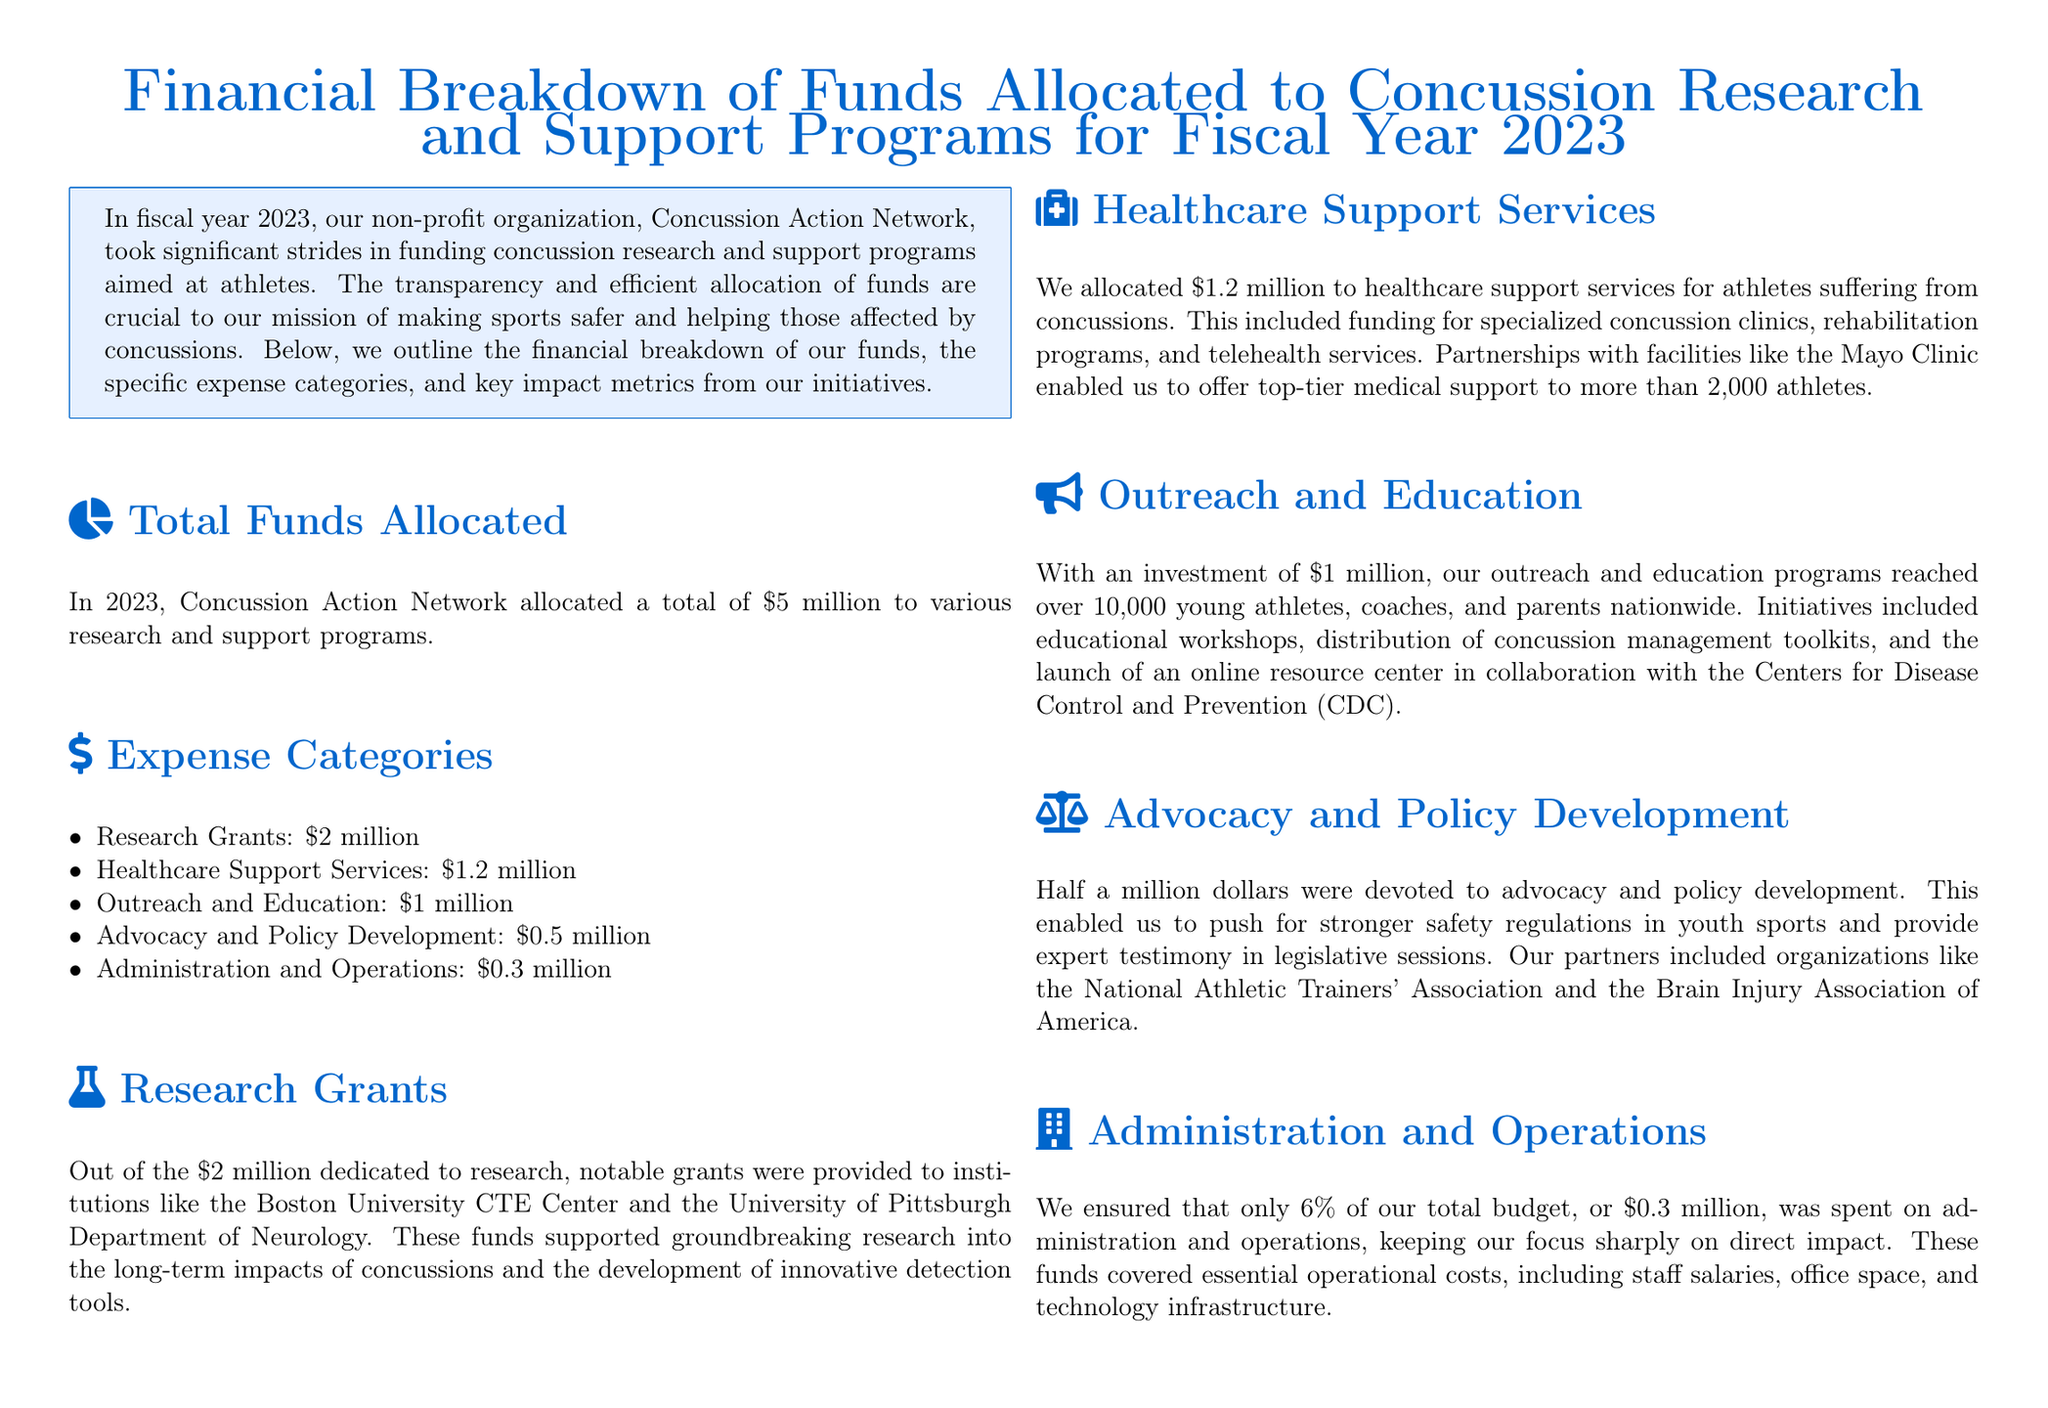What is the total funds allocated? The total funds allocated is stated at the beginning of the document, amounting to $5 million.
Answer: $5 million How much was allocated to research grants? The document specifies that $2 million was allocated to research grants.
Answer: $2 million Which organization received research grants? The document mentions that significant grants were given to institutions, specifically the Boston University CTE Center and the University of Pittsburgh Department of Neurology.
Answer: Boston University CTE Center and the University of Pittsburgh How many athletes received healthcare support services? The document states that more than 2,000 athletes received direct healthcare services through the allocated funding.
Answer: Over 2,000 athletes What percentage of the budget was spent on administration and operations? The document mentions that only 6% of the total budget was allocated for administration and operations.
Answer: 6% How many educational programs were launched? The educational reach covered more than 10,000 individuals through various outreach initiatives.
Answer: More than 10,000 individuals How much funding was directed to advocacy and policy development? The document outlines that half a million dollars, or $0.5 million, was allocated for advocacy and policy development.
Answer: $0.5 million How many peer-reviewed journal articles resulted from the funded projects? The impact metrics indicate that the funded projects resulted in 15 peer-reviewed journal articles.
Answer: 15 What was the total impact of legislative contributions? The document mentions that contributions from the organization helped in passing three state laws improving concussion protocols.
Answer: Three state laws 